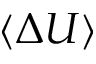Convert formula to latex. <formula><loc_0><loc_0><loc_500><loc_500>\langle \Delta U \rangle</formula> 